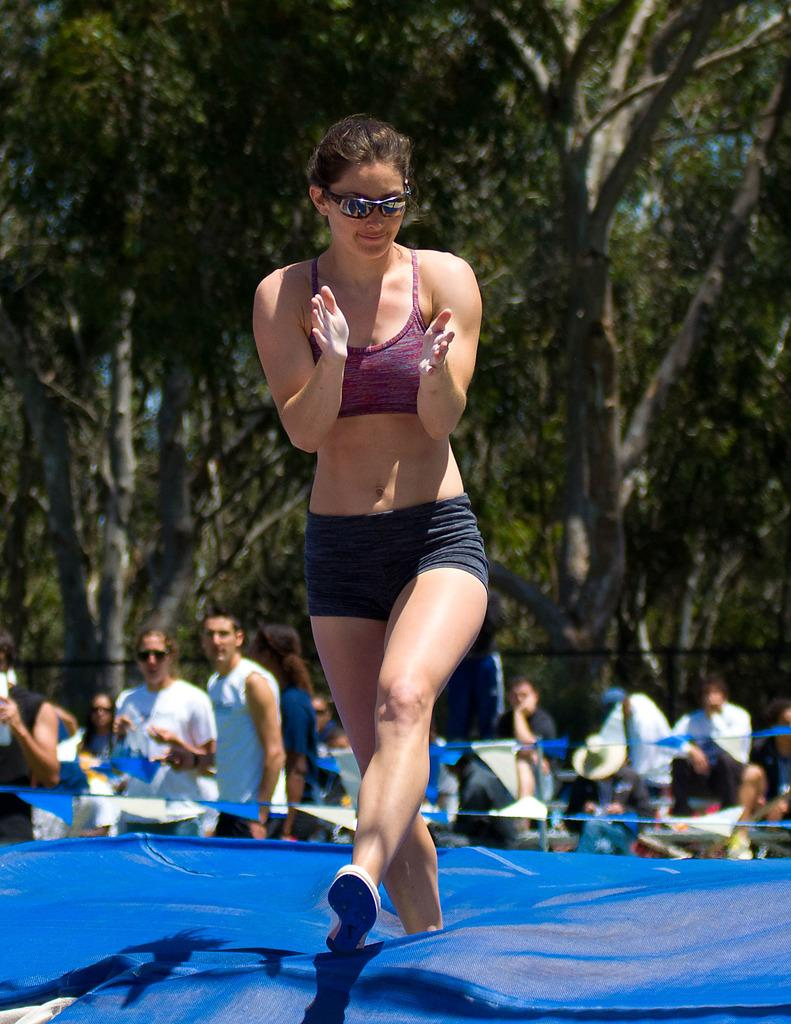Who is the main subject in the image? There is a woman in the image. What is the woman doing in the image? The woman is clapping. What is the color of the surface the woman is standing on? The woman is on a blue surface. Are there any other people in the image? Yes, there are other people in the image. What can be seen in the background of the image? The background of the image includes tall structures or people. What type of lock can be seen in the image? There is no lock present in the image. What is the aftermath of the event in the image? The image does not depict an event, so there is no aftermath to describe. 